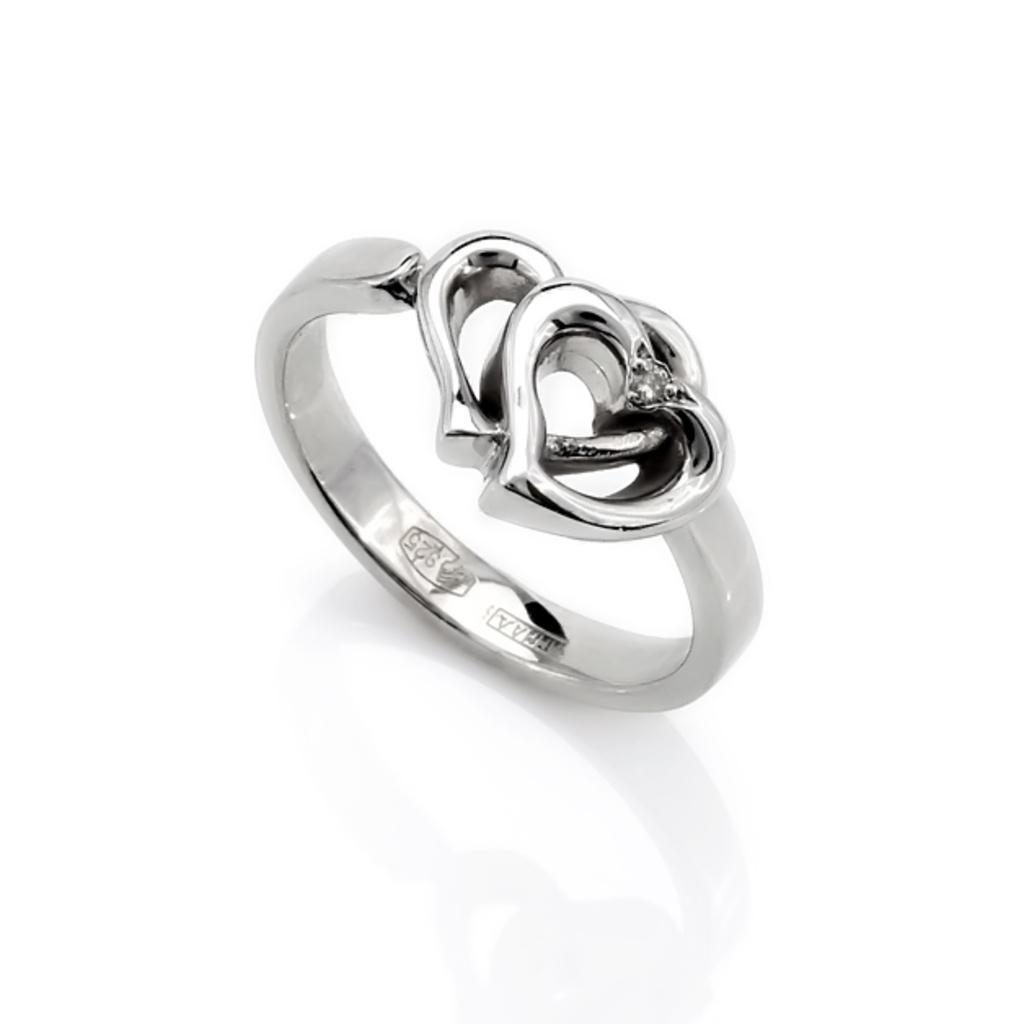Can you describe this image briefly? In this image I can see the ring and the background is in white color. 